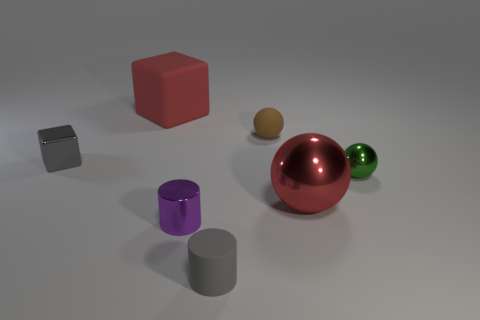The green metal object that is the same size as the brown rubber ball is what shape?
Offer a terse response. Sphere. What shape is the big thing that is on the left side of the matte cylinder?
Your response must be concise. Cube. Are there fewer purple metallic cylinders that are in front of the small brown matte ball than matte blocks that are in front of the red matte object?
Offer a very short reply. No. Does the purple shiny thing have the same size as the red object left of the purple metallic object?
Give a very brief answer. No. How many gray blocks have the same size as the purple object?
Ensure brevity in your answer.  1. There is a cylinder that is the same material as the small green object; what is its color?
Your answer should be very brief. Purple. Is the number of metallic balls greater than the number of tiny yellow metal cylinders?
Provide a short and direct response. Yes. Is the material of the tiny green object the same as the large red cube?
Keep it short and to the point. No. The brown thing that is made of the same material as the large red cube is what shape?
Provide a succinct answer. Sphere. Is the number of green rubber cylinders less than the number of small brown rubber objects?
Keep it short and to the point. Yes. 